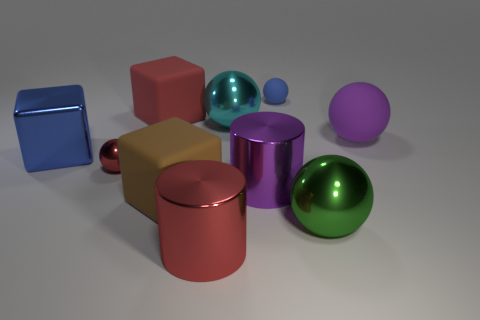What number of things are either big rubber things that are on the right side of the blue rubber thing or big balls in front of the large blue block?
Your answer should be compact. 2. Is the material of the small red sphere the same as the large purple thing that is to the left of the blue rubber object?
Provide a succinct answer. Yes. What shape is the red object that is on the right side of the tiny red metallic thing and behind the large green thing?
Make the answer very short. Cube. What number of other objects are there of the same color as the tiny metal thing?
Your answer should be very brief. 2. There is a tiny metallic thing; what shape is it?
Your answer should be compact. Sphere. The large cylinder that is in front of the green metal ball to the left of the purple matte sphere is what color?
Keep it short and to the point. Red. There is a small shiny object; is its color the same as the small ball that is behind the big blue object?
Provide a succinct answer. No. What material is the large thing that is both behind the large blue object and left of the cyan object?
Your answer should be very brief. Rubber. Is there a purple rubber object of the same size as the green sphere?
Give a very brief answer. Yes. What material is the brown thing that is the same size as the red rubber object?
Offer a terse response. Rubber. 